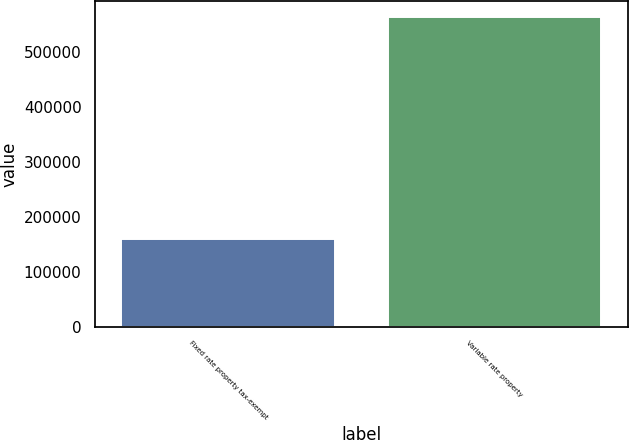<chart> <loc_0><loc_0><loc_500><loc_500><bar_chart><fcel>Fixed rate property tax-exempt<fcel>Variable rate property<nl><fcel>158620<fcel>563351<nl></chart> 